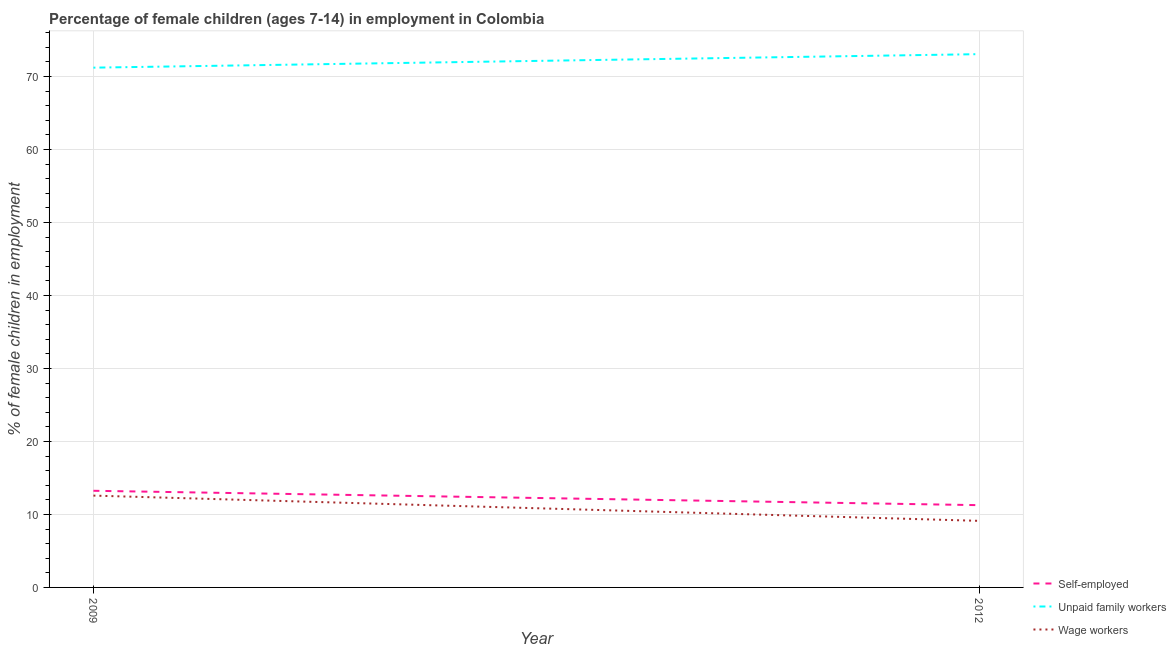Does the line corresponding to percentage of children employed as unpaid family workers intersect with the line corresponding to percentage of children employed as wage workers?
Offer a terse response. No. What is the percentage of children employed as unpaid family workers in 2012?
Keep it short and to the point. 73.06. Across all years, what is the maximum percentage of self employed children?
Offer a very short reply. 13.24. Across all years, what is the minimum percentage of children employed as unpaid family workers?
Provide a short and direct response. 71.21. What is the total percentage of self employed children in the graph?
Give a very brief answer. 24.51. What is the difference between the percentage of self employed children in 2009 and that in 2012?
Your answer should be compact. 1.97. What is the difference between the percentage of children employed as wage workers in 2012 and the percentage of children employed as unpaid family workers in 2009?
Provide a succinct answer. -62.09. What is the average percentage of self employed children per year?
Your answer should be very brief. 12.25. In the year 2012, what is the difference between the percentage of children employed as unpaid family workers and percentage of self employed children?
Make the answer very short. 61.79. In how many years, is the percentage of children employed as wage workers greater than 74 %?
Keep it short and to the point. 0. What is the ratio of the percentage of self employed children in 2009 to that in 2012?
Offer a terse response. 1.17. In how many years, is the percentage of children employed as unpaid family workers greater than the average percentage of children employed as unpaid family workers taken over all years?
Your response must be concise. 1. Is it the case that in every year, the sum of the percentage of self employed children and percentage of children employed as unpaid family workers is greater than the percentage of children employed as wage workers?
Offer a terse response. Yes. Does the percentage of children employed as unpaid family workers monotonically increase over the years?
Offer a very short reply. Yes. Is the percentage of children employed as wage workers strictly greater than the percentage of children employed as unpaid family workers over the years?
Provide a succinct answer. No. Is the percentage of children employed as wage workers strictly less than the percentage of children employed as unpaid family workers over the years?
Your response must be concise. Yes. How many lines are there?
Ensure brevity in your answer.  3. How many years are there in the graph?
Keep it short and to the point. 2. Does the graph contain any zero values?
Give a very brief answer. No. How many legend labels are there?
Your answer should be compact. 3. What is the title of the graph?
Your answer should be very brief. Percentage of female children (ages 7-14) in employment in Colombia. What is the label or title of the Y-axis?
Provide a succinct answer. % of female children in employment. What is the % of female children in employment of Self-employed in 2009?
Your answer should be compact. 13.24. What is the % of female children in employment in Unpaid family workers in 2009?
Offer a terse response. 71.21. What is the % of female children in employment of Wage workers in 2009?
Offer a terse response. 12.58. What is the % of female children in employment in Self-employed in 2012?
Provide a short and direct response. 11.27. What is the % of female children in employment in Unpaid family workers in 2012?
Ensure brevity in your answer.  73.06. What is the % of female children in employment of Wage workers in 2012?
Ensure brevity in your answer.  9.12. Across all years, what is the maximum % of female children in employment in Self-employed?
Make the answer very short. 13.24. Across all years, what is the maximum % of female children in employment in Unpaid family workers?
Make the answer very short. 73.06. Across all years, what is the maximum % of female children in employment of Wage workers?
Provide a succinct answer. 12.58. Across all years, what is the minimum % of female children in employment of Self-employed?
Your response must be concise. 11.27. Across all years, what is the minimum % of female children in employment in Unpaid family workers?
Ensure brevity in your answer.  71.21. Across all years, what is the minimum % of female children in employment in Wage workers?
Give a very brief answer. 9.12. What is the total % of female children in employment in Self-employed in the graph?
Your answer should be very brief. 24.51. What is the total % of female children in employment in Unpaid family workers in the graph?
Offer a terse response. 144.27. What is the total % of female children in employment in Wage workers in the graph?
Provide a succinct answer. 21.7. What is the difference between the % of female children in employment in Self-employed in 2009 and that in 2012?
Provide a short and direct response. 1.97. What is the difference between the % of female children in employment in Unpaid family workers in 2009 and that in 2012?
Provide a short and direct response. -1.85. What is the difference between the % of female children in employment in Wage workers in 2009 and that in 2012?
Offer a terse response. 3.46. What is the difference between the % of female children in employment in Self-employed in 2009 and the % of female children in employment in Unpaid family workers in 2012?
Your response must be concise. -59.82. What is the difference between the % of female children in employment of Self-employed in 2009 and the % of female children in employment of Wage workers in 2012?
Offer a terse response. 4.12. What is the difference between the % of female children in employment in Unpaid family workers in 2009 and the % of female children in employment in Wage workers in 2012?
Give a very brief answer. 62.09. What is the average % of female children in employment of Self-employed per year?
Ensure brevity in your answer.  12.26. What is the average % of female children in employment in Unpaid family workers per year?
Keep it short and to the point. 72.14. What is the average % of female children in employment of Wage workers per year?
Provide a short and direct response. 10.85. In the year 2009, what is the difference between the % of female children in employment of Self-employed and % of female children in employment of Unpaid family workers?
Offer a terse response. -57.97. In the year 2009, what is the difference between the % of female children in employment of Self-employed and % of female children in employment of Wage workers?
Provide a succinct answer. 0.66. In the year 2009, what is the difference between the % of female children in employment in Unpaid family workers and % of female children in employment in Wage workers?
Your response must be concise. 58.63. In the year 2012, what is the difference between the % of female children in employment of Self-employed and % of female children in employment of Unpaid family workers?
Provide a succinct answer. -61.79. In the year 2012, what is the difference between the % of female children in employment in Self-employed and % of female children in employment in Wage workers?
Offer a terse response. 2.15. In the year 2012, what is the difference between the % of female children in employment of Unpaid family workers and % of female children in employment of Wage workers?
Provide a short and direct response. 63.94. What is the ratio of the % of female children in employment in Self-employed in 2009 to that in 2012?
Ensure brevity in your answer.  1.17. What is the ratio of the % of female children in employment of Unpaid family workers in 2009 to that in 2012?
Keep it short and to the point. 0.97. What is the ratio of the % of female children in employment in Wage workers in 2009 to that in 2012?
Provide a succinct answer. 1.38. What is the difference between the highest and the second highest % of female children in employment in Self-employed?
Offer a very short reply. 1.97. What is the difference between the highest and the second highest % of female children in employment in Unpaid family workers?
Keep it short and to the point. 1.85. What is the difference between the highest and the second highest % of female children in employment in Wage workers?
Your answer should be very brief. 3.46. What is the difference between the highest and the lowest % of female children in employment of Self-employed?
Make the answer very short. 1.97. What is the difference between the highest and the lowest % of female children in employment in Unpaid family workers?
Give a very brief answer. 1.85. What is the difference between the highest and the lowest % of female children in employment of Wage workers?
Give a very brief answer. 3.46. 